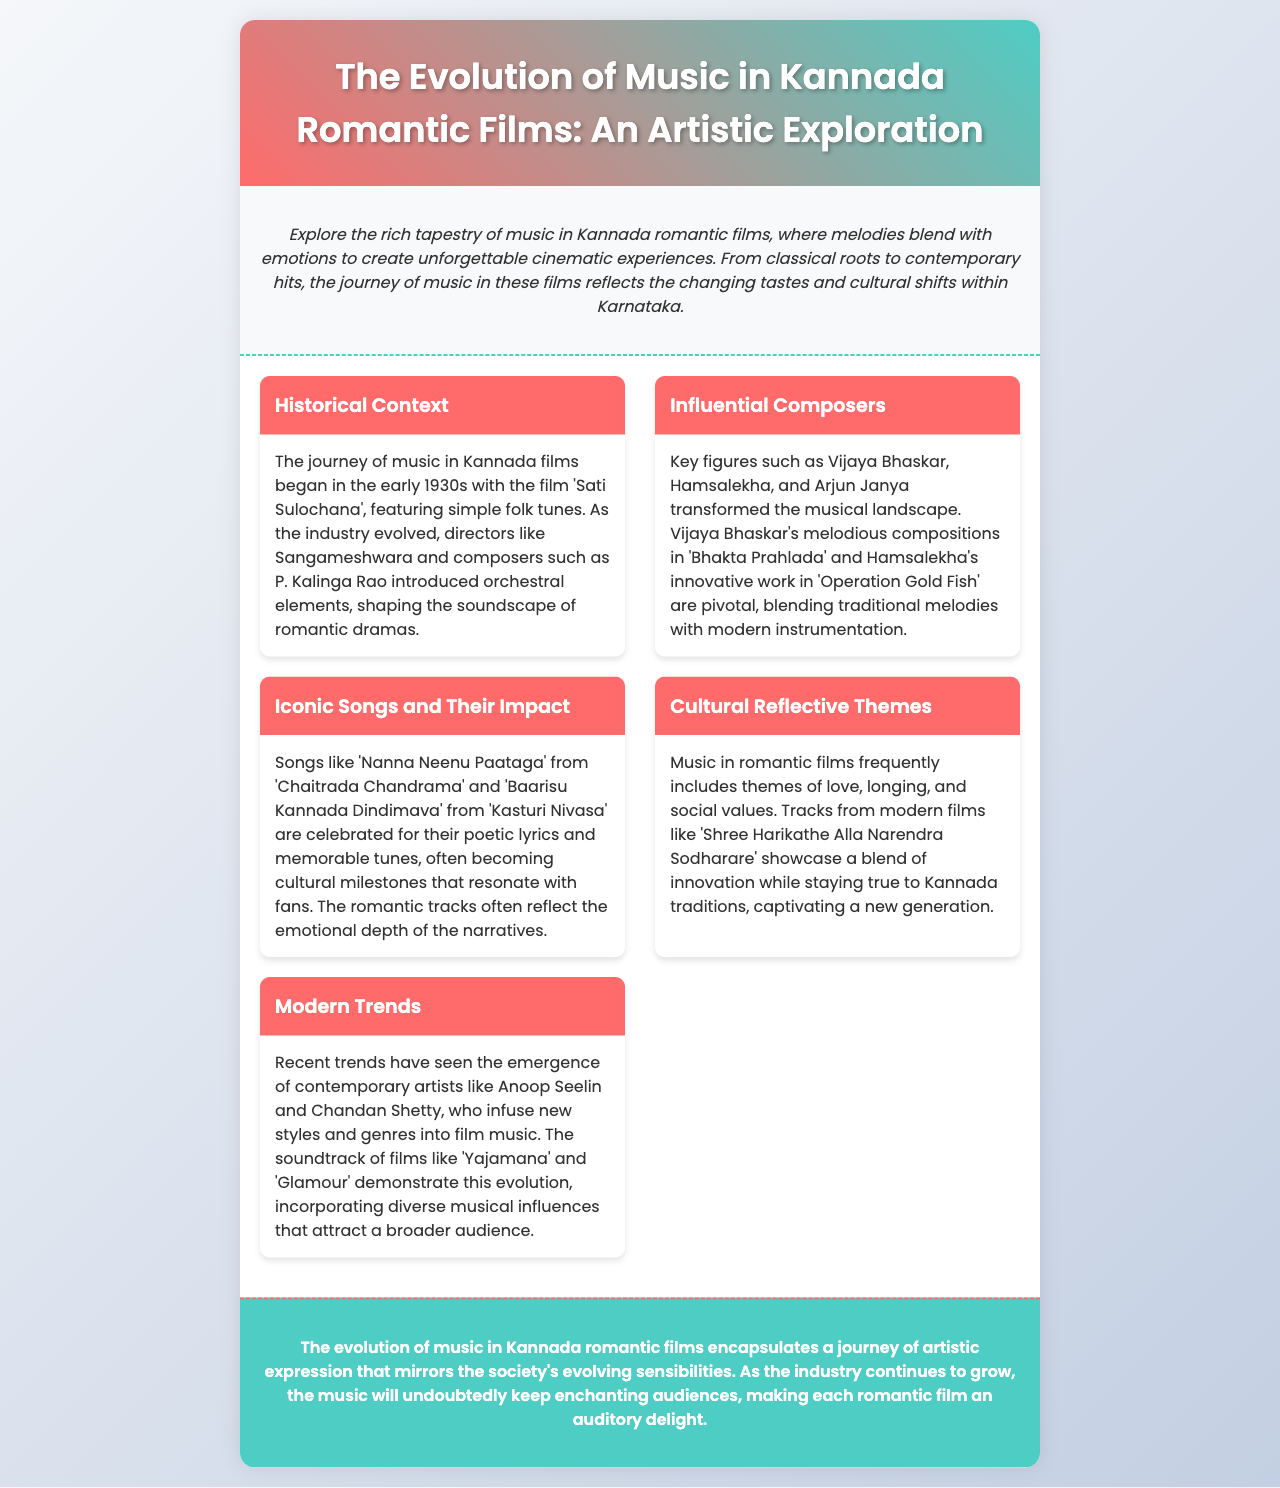What year did the journey of Kannada film music begin? The document states that the journey began in the early 1930s with the film 'Sati Sulochana'.
Answer: early 1930s Who were the key influential composers mentioned? The influential composers listed are Vijaya Bhaskar, Hamsalekha, and Arjun Janya.
Answer: Vijaya Bhaskar, Hamsalekha, Arjun Janya Which song is mentioned as an iconic track from 'Chaitrada Chandrama'? The document mentions 'Nanna Neenu Paataga' as an iconic song from 'Chaitrada Chandrama'.
Answer: Nanna Neenu Paataga What modern trends are highlighted in the document? The document discusses the emergence of contemporary artists like Anoop Seelin and Chandan Shetty as modern trends.
Answer: contemporary artists What themes does the music in romantic films frequently include? The document states that music includes themes of love, longing, and social values.
Answer: love, longing, social values Which film's soundtrack illustrates modern trends in music? The soundtrack of the film 'Yajamana' is mentioned as a demonstration of modern trends.
Answer: Yajamana 